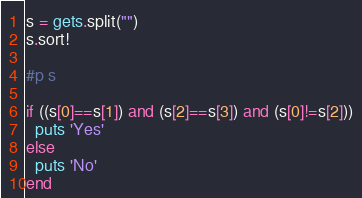<code> <loc_0><loc_0><loc_500><loc_500><_Ruby_>s = gets.split("")
s.sort!

#p s

if ((s[0]==s[1]) and (s[2]==s[3]) and (s[0]!=s[2]))
  puts 'Yes'
else
  puts 'No'
end

</code> 